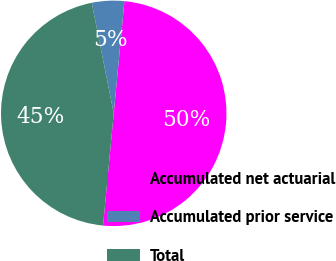Convert chart. <chart><loc_0><loc_0><loc_500><loc_500><pie_chart><fcel>Accumulated net actuarial<fcel>Accumulated prior service<fcel>Total<nl><fcel>50.0%<fcel>4.64%<fcel>45.36%<nl></chart> 